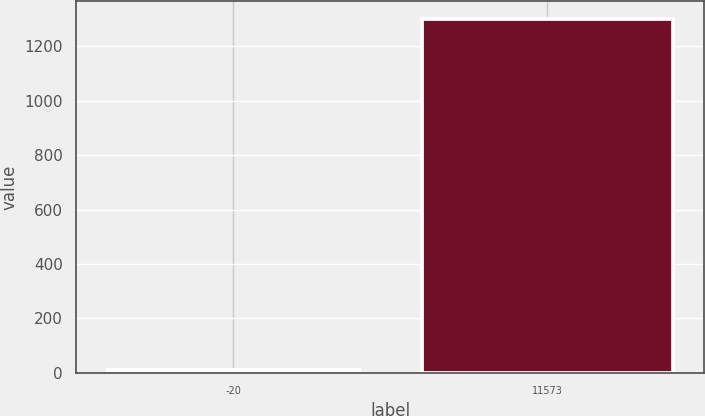Convert chart to OTSL. <chart><loc_0><loc_0><loc_500><loc_500><bar_chart><fcel>-20<fcel>11573<nl><fcel>10<fcel>1302<nl></chart> 